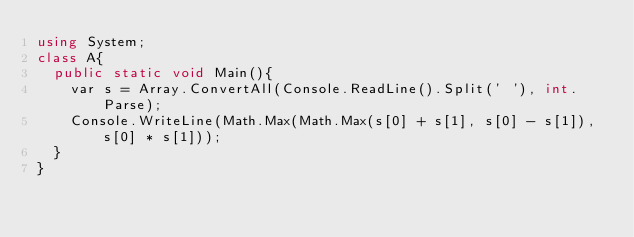<code> <loc_0><loc_0><loc_500><loc_500><_C#_>using System;
class A{
  public static void Main(){
    var s = Array.ConvertAll(Console.ReadLine().Split(' '), int.Parse);
    Console.WriteLine(Math.Max(Math.Max(s[0] + s[1], s[0] - s[1]), s[0] * s[1]));
  }
}</code> 